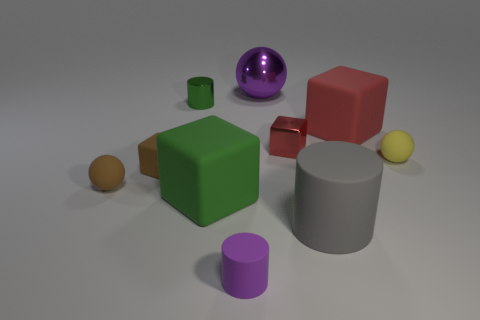Subtract 1 blocks. How many blocks are left? 3 Subtract all blocks. How many objects are left? 6 Subtract 0 cyan cylinders. How many objects are left? 10 Subtract all large blue rubber spheres. Subtract all tiny matte spheres. How many objects are left? 8 Add 3 tiny matte cylinders. How many tiny matte cylinders are left? 4 Add 2 tiny metallic cylinders. How many tiny metallic cylinders exist? 3 